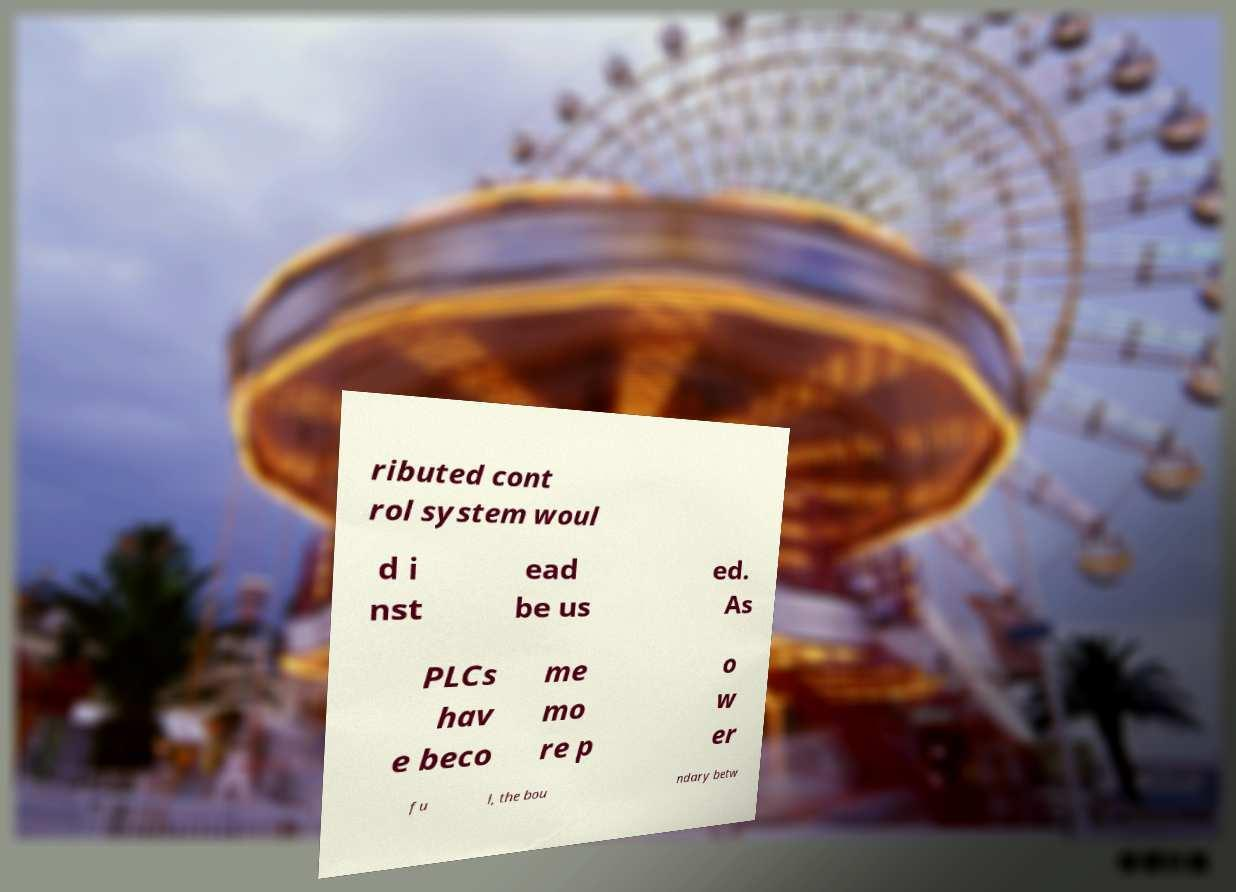For documentation purposes, I need the text within this image transcribed. Could you provide that? ributed cont rol system woul d i nst ead be us ed. As PLCs hav e beco me mo re p o w er fu l, the bou ndary betw 